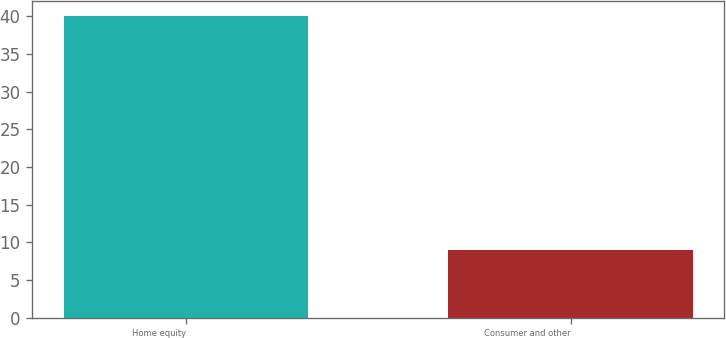Convert chart to OTSL. <chart><loc_0><loc_0><loc_500><loc_500><bar_chart><fcel>Home equity<fcel>Consumer and other<nl><fcel>40<fcel>9<nl></chart> 